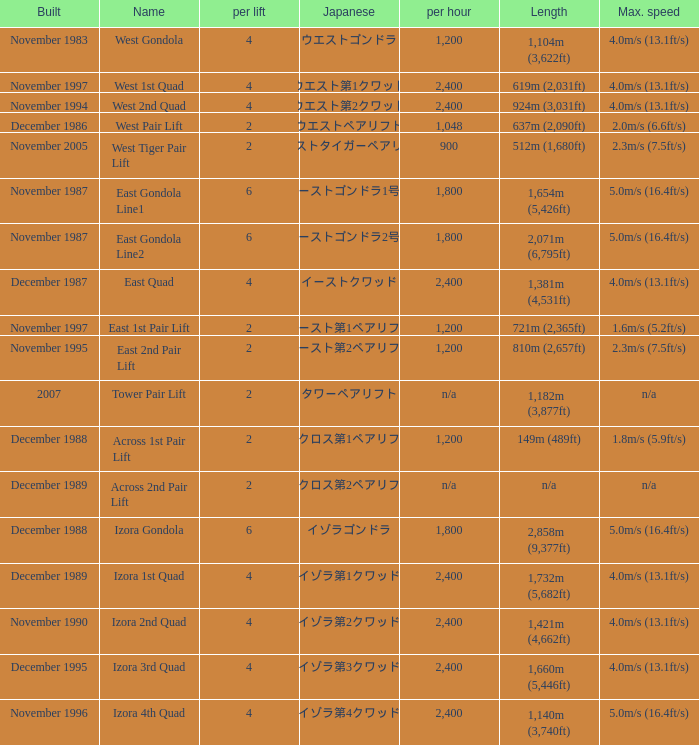How heavy is the  maximum 6.0. 